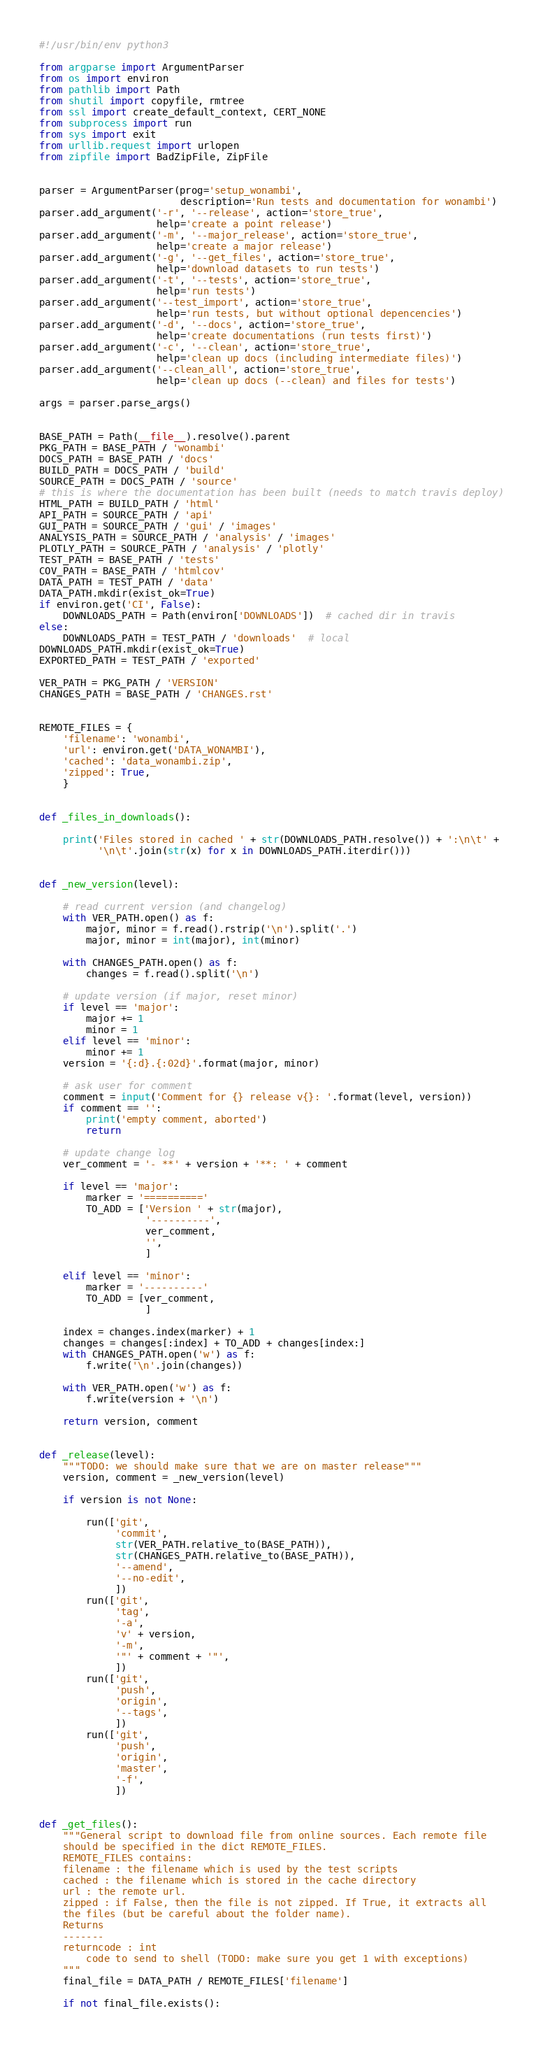Convert code to text. <code><loc_0><loc_0><loc_500><loc_500><_Python_>#!/usr/bin/env python3

from argparse import ArgumentParser
from os import environ
from pathlib import Path
from shutil import copyfile, rmtree
from ssl import create_default_context, CERT_NONE
from subprocess import run
from sys import exit
from urllib.request import urlopen
from zipfile import BadZipFile, ZipFile


parser = ArgumentParser(prog='setup_wonambi',
                        description='Run tests and documentation for wonambi')
parser.add_argument('-r', '--release', action='store_true',
                    help='create a point release')
parser.add_argument('-m', '--major_release', action='store_true',
                    help='create a major release')
parser.add_argument('-g', '--get_files', action='store_true',
                    help='download datasets to run tests')
parser.add_argument('-t', '--tests', action='store_true',
                    help='run tests')
parser.add_argument('--test_import', action='store_true',
                    help='run tests, but without optional depencencies')
parser.add_argument('-d', '--docs', action='store_true',
                    help='create documentations (run tests first)')
parser.add_argument('-c', '--clean', action='store_true',
                    help='clean up docs (including intermediate files)')
parser.add_argument('--clean_all', action='store_true',
                    help='clean up docs (--clean) and files for tests')

args = parser.parse_args()


BASE_PATH = Path(__file__).resolve().parent
PKG_PATH = BASE_PATH / 'wonambi'
DOCS_PATH = BASE_PATH / 'docs'
BUILD_PATH = DOCS_PATH / 'build'
SOURCE_PATH = DOCS_PATH / 'source'
# this is where the documentation has been built (needs to match travis deploy)
HTML_PATH = BUILD_PATH / 'html'
API_PATH = SOURCE_PATH / 'api'
GUI_PATH = SOURCE_PATH / 'gui' / 'images'
ANALYSIS_PATH = SOURCE_PATH / 'analysis' / 'images'
PLOTLY_PATH = SOURCE_PATH / 'analysis' / 'plotly'
TEST_PATH = BASE_PATH / 'tests'
COV_PATH = BASE_PATH / 'htmlcov'
DATA_PATH = TEST_PATH / 'data'
DATA_PATH.mkdir(exist_ok=True)
if environ.get('CI', False):
    DOWNLOADS_PATH = Path(environ['DOWNLOADS'])  # cached dir in travis
else:
    DOWNLOADS_PATH = TEST_PATH / 'downloads'  # local
DOWNLOADS_PATH.mkdir(exist_ok=True)
EXPORTED_PATH = TEST_PATH / 'exported'

VER_PATH = PKG_PATH / 'VERSION'
CHANGES_PATH = BASE_PATH / 'CHANGES.rst'


REMOTE_FILES = {
    'filename': 'wonambi',
    'url': environ.get('DATA_WONAMBI'),
    'cached': 'data_wonambi.zip',
    'zipped': True,
    }


def _files_in_downloads():

    print('Files stored in cached ' + str(DOWNLOADS_PATH.resolve()) + ':\n\t' +
          '\n\t'.join(str(x) for x in DOWNLOADS_PATH.iterdir()))


def _new_version(level):

    # read current version (and changelog)
    with VER_PATH.open() as f:
        major, minor = f.read().rstrip('\n').split('.')
        major, minor = int(major), int(minor)

    with CHANGES_PATH.open() as f:
        changes = f.read().split('\n')

    # update version (if major, reset minor)
    if level == 'major':
        major += 1
        minor = 1
    elif level == 'minor':
        minor += 1
    version = '{:d}.{:02d}'.format(major, minor)

    # ask user for comment
    comment = input('Comment for {} release v{}: '.format(level, version))
    if comment == '':
        print('empty comment, aborted')
        return

    # update change log
    ver_comment = '- **' + version + '**: ' + comment

    if level == 'major':
        marker = '=========='
        TO_ADD = ['Version ' + str(major),
                  '----------',
                  ver_comment,
                  '',
                  ]

    elif level == 'minor':
        marker = '----------'
        TO_ADD = [ver_comment,
                  ]

    index = changes.index(marker) + 1
    changes = changes[:index] + TO_ADD + changes[index:]
    with CHANGES_PATH.open('w') as f:
        f.write('\n'.join(changes))

    with VER_PATH.open('w') as f:
        f.write(version + '\n')

    return version, comment


def _release(level):
    """TODO: we should make sure that we are on master release"""
    version, comment = _new_version(level)

    if version is not None:

        run(['git',
             'commit',
             str(VER_PATH.relative_to(BASE_PATH)),
             str(CHANGES_PATH.relative_to(BASE_PATH)),
             '--amend',
             '--no-edit',
             ])
        run(['git',
             'tag',
             '-a',
             'v' + version,
             '-m',
             '"' + comment + '"',
             ])
        run(['git',
             'push',
             'origin',
             '--tags',
             ])
        run(['git',
             'push',
             'origin',
             'master',
             '-f',
             ])


def _get_files():
    """General script to download file from online sources. Each remote file
    should be specified in the dict REMOTE_FILES.
    REMOTE_FILES contains:
    filename : the filename which is used by the test scripts
    cached : the filename which is stored in the cache directory
    url : the remote url.
    zipped : if False, then the file is not zipped. If True, it extracts all
    the files (but be careful about the folder name).
    Returns
    -------
    returncode : int
        code to send to shell (TODO: make sure you get 1 with exceptions)
    """
    final_file = DATA_PATH / REMOTE_FILES['filename']

    if not final_file.exists():</code> 